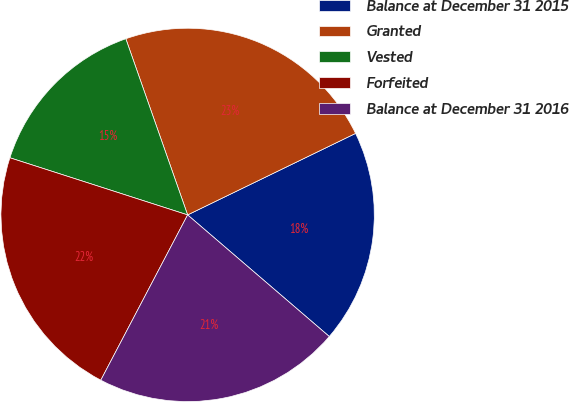<chart> <loc_0><loc_0><loc_500><loc_500><pie_chart><fcel>Balance at December 31 2015<fcel>Granted<fcel>Vested<fcel>Forfeited<fcel>Balance at December 31 2016<nl><fcel>18.48%<fcel>23.18%<fcel>14.68%<fcel>22.25%<fcel>21.41%<nl></chart> 